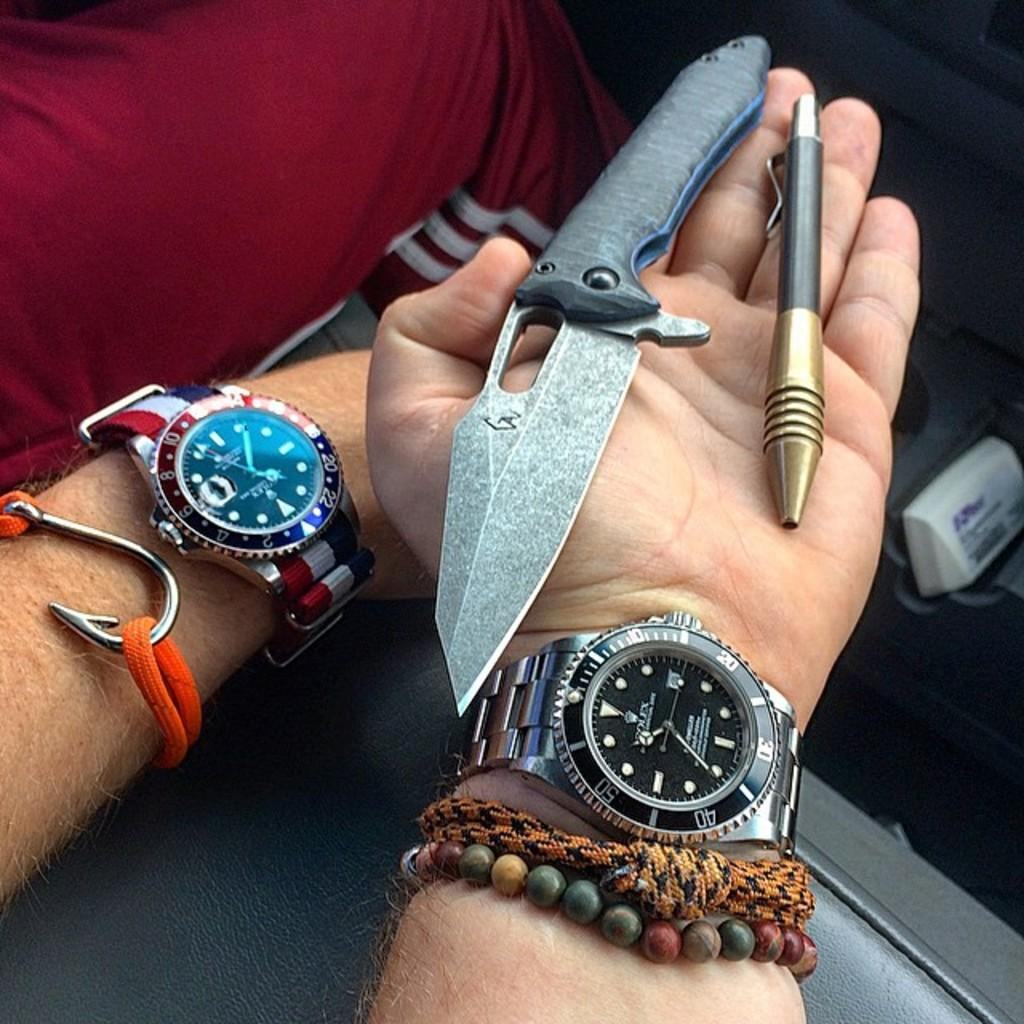<image>
Describe the image concisely. A man wearing a Rolex brand watch with a knife and pen in his hand. 